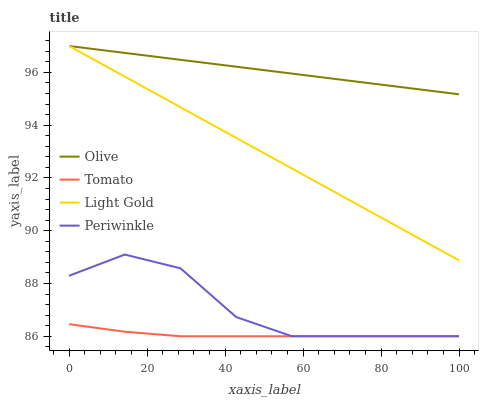Does Tomato have the minimum area under the curve?
Answer yes or no. Yes. Does Olive have the maximum area under the curve?
Answer yes or no. Yes. Does Periwinkle have the minimum area under the curve?
Answer yes or no. No. Does Periwinkle have the maximum area under the curve?
Answer yes or no. No. Is Light Gold the smoothest?
Answer yes or no. Yes. Is Periwinkle the roughest?
Answer yes or no. Yes. Is Tomato the smoothest?
Answer yes or no. No. Is Tomato the roughest?
Answer yes or no. No. Does Tomato have the lowest value?
Answer yes or no. Yes. Does Light Gold have the lowest value?
Answer yes or no. No. Does Light Gold have the highest value?
Answer yes or no. Yes. Does Periwinkle have the highest value?
Answer yes or no. No. Is Tomato less than Olive?
Answer yes or no. Yes. Is Olive greater than Periwinkle?
Answer yes or no. Yes. Does Periwinkle intersect Tomato?
Answer yes or no. Yes. Is Periwinkle less than Tomato?
Answer yes or no. No. Is Periwinkle greater than Tomato?
Answer yes or no. No. Does Tomato intersect Olive?
Answer yes or no. No. 